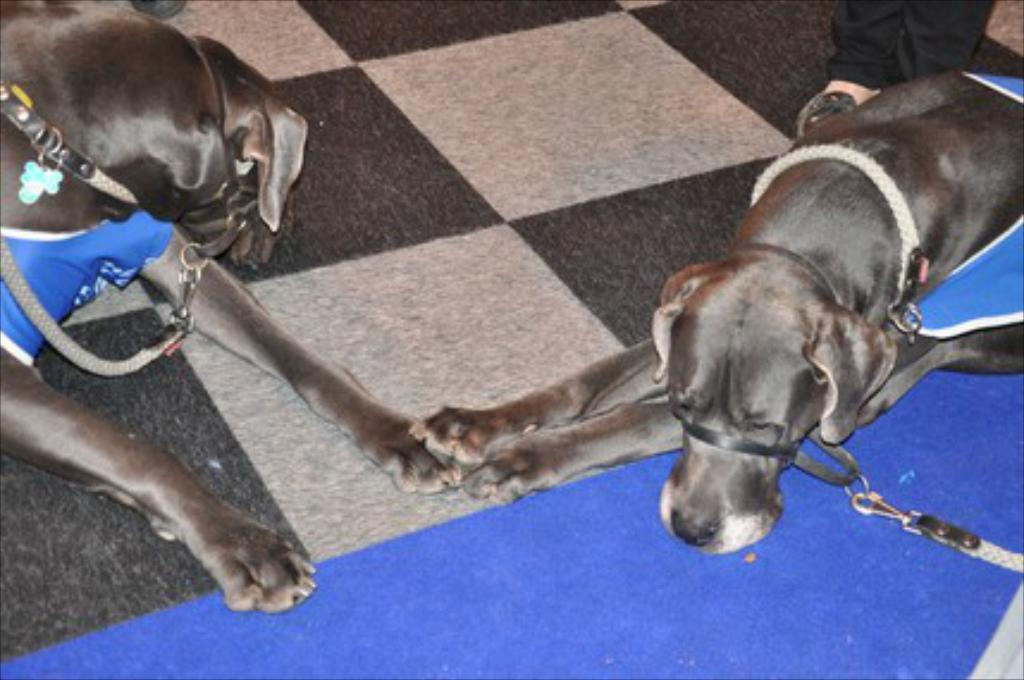How many dogs are in the image? There are two black color dogs in the image. What color is the mat in the image? There is a blue color mat in the image. What type of flooring is visible in the image? There are white and black color tiles in the image. Where is the map located in the image? There is no map present in the image. Is there any water visible in the image? There is no water visible in the image. 